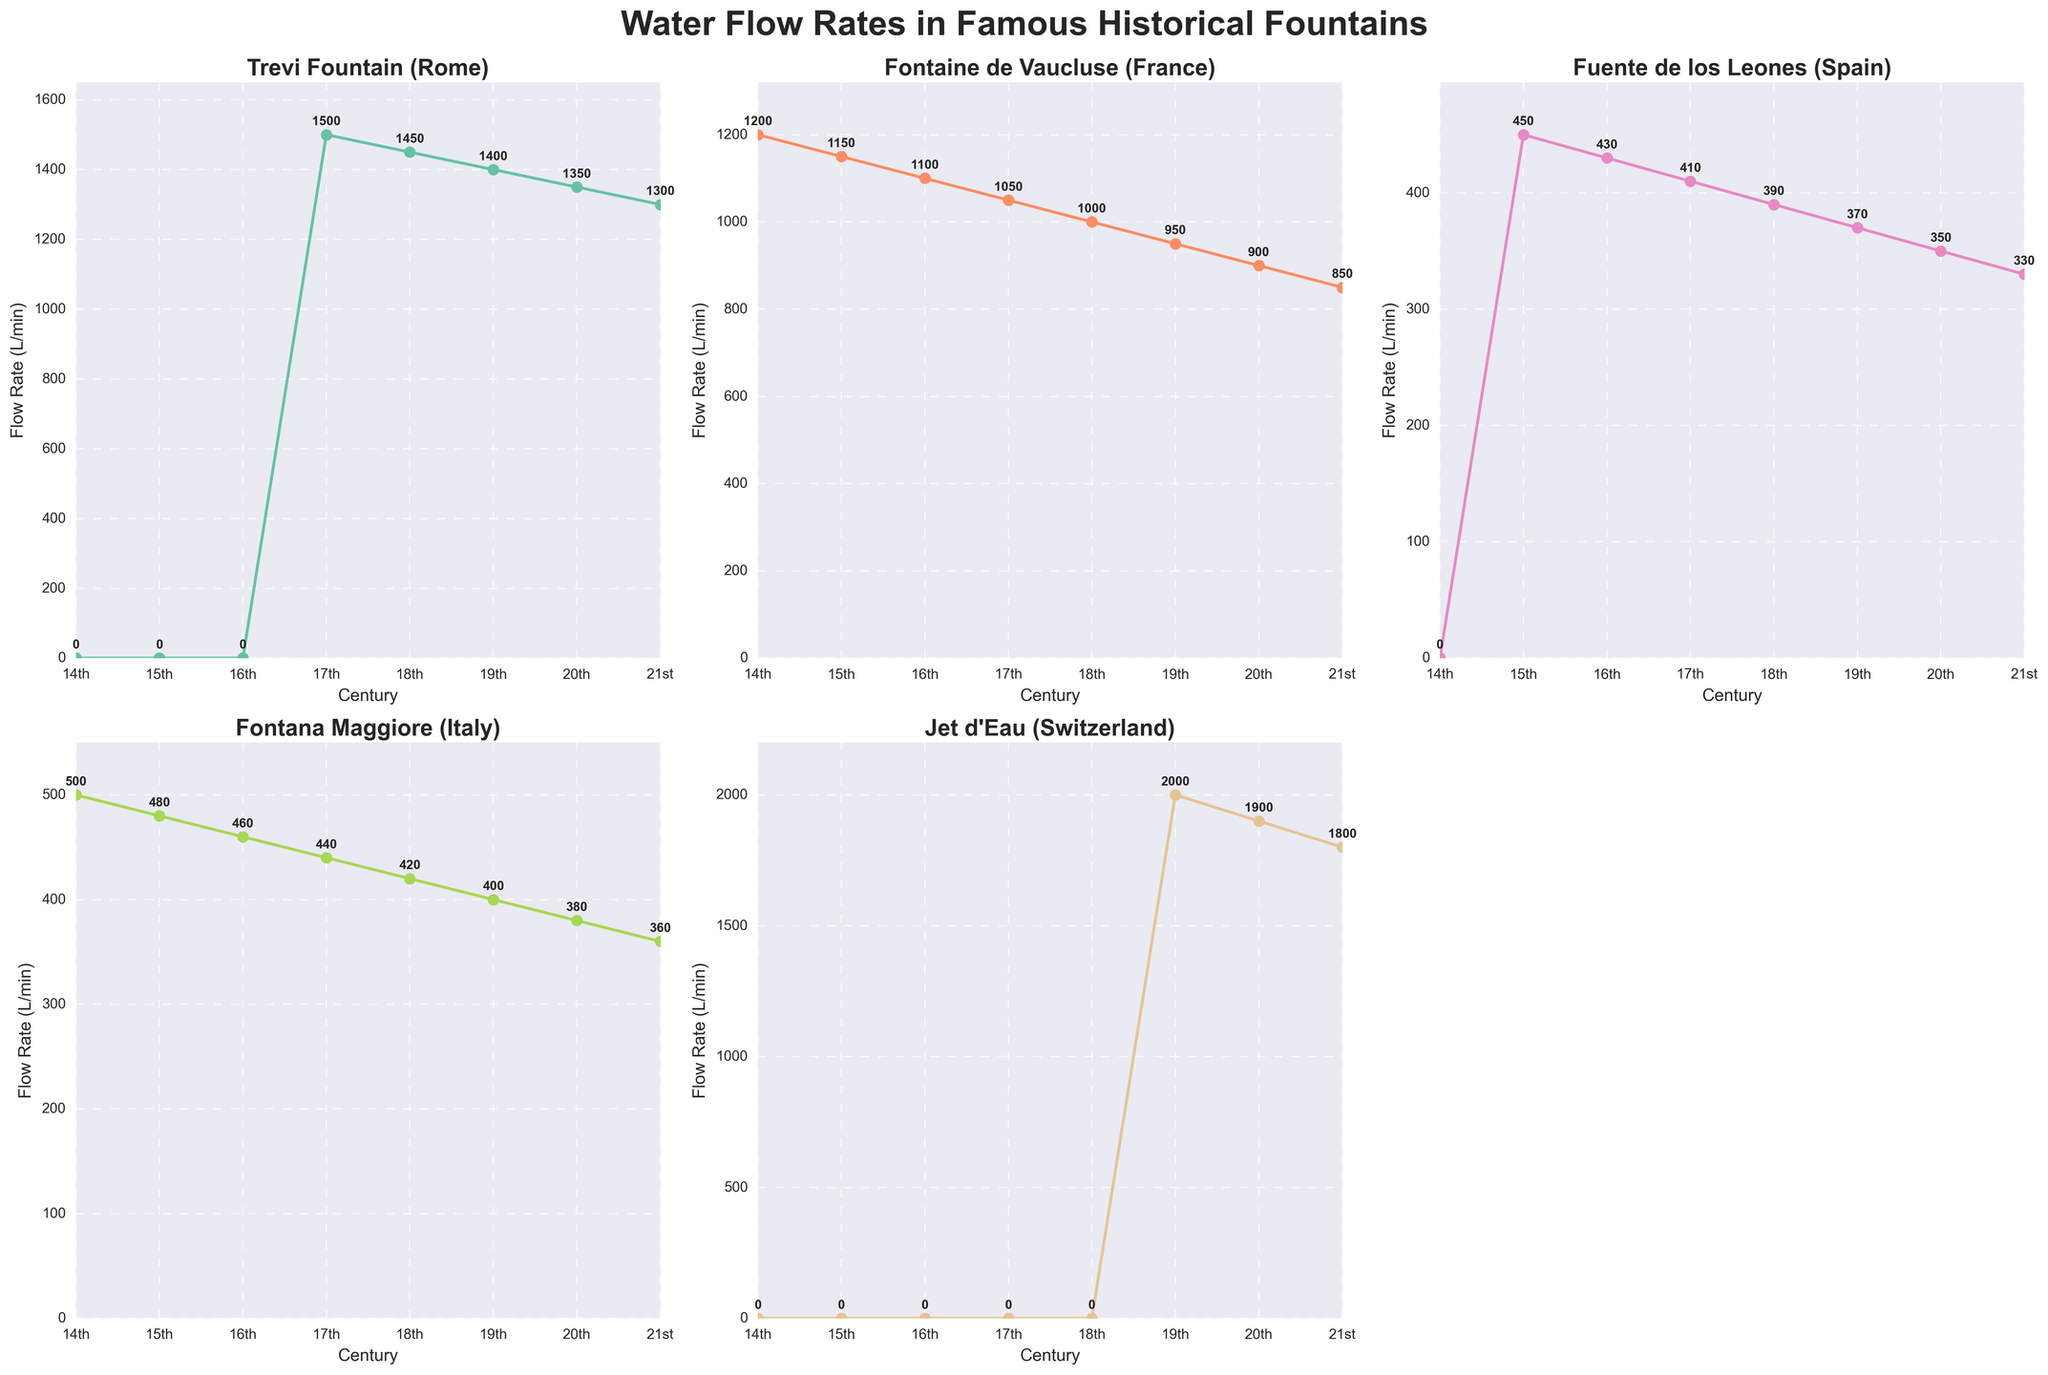Which fountain had the highest flow rate in the 17th century? To determine which fountain had the highest flow rate, locate the 17th-century column and compare the values for each fountain. The Trevi Fountain (Rome) has a flow rate of 1500 L/min, which is the highest.
Answer: Trevi Fountain (Rome) How did the flow rate of Jet d'Eau (Switzerland) change from the 19th to the 21st century? Find the flow rates in the 19th, 20th, and 21st centuries for Jet d'Eau (Switzerland). The values are 2000, 1900, and 1800 L/min, respectively. The flow rate decreased by 200 L/min each century.
Answer: Decreased Which century shows the largest difference in flow rate between Trevi Fountain (Rome) and Fontaine de Vaucluse (France)? Calculate the difference between these two fountains for each century. The difference is largest in the 17th century (1500 - 1050 = 450 L/min).
Answer: 17th century What is the average flow rate of Fuente de los Leones (Spain) across all centuries? Sum the flow rates for Fuente de los Leones in each century: 0 + 450 + 430 + 410 + 390 + 370 + 350 + 330 = 2730. There are 8 values, so the average is 2730 / 8.
Answer: 341.25 L/min During which century was the flow rate of Fontana Maggiore (Italy) greater than that of Fuente de los Leones (Spain) by at least 100 L/min? Compare the flow rates for each century. In the 14th (500 - 0 = 500) and 15th (480 - 450 = 30) centuries, the difference is at least 100. This only applies to the 14th century.
Answer: 14th century Which fountains had no recorded flow rates in the 14th century? Look at the 14th-century column: Trevi Fountain (Rome), Fuente de los Leones (Spain), and Jet d'Eau (Switzerland) have zero values.
Answer: Trevi Fountain (Rome), Fuente de los Leones (Spain), Jet d'Eau (Switzerland) Which fountain shows the most consistent flow rate across centuries? Observe the stability of flow rates over centuries for each fountain. Fontaine de Vaucluse (France) demonstrates the smallest variations, starting at 1200 L/min in the 14th century and ending at 850 L/min in the 21st.
Answer: Fontaine de Vaucluse (France) What is the median flow rate of Fontana Maggiore (Italy)? Arrange the flow rates in numerical order: 360, 380, 400, 420, 440, 460, 480, 500. The median is the average of the 4th and 5th values: (420 + 440) / 2.
Answer: 430 L/min 